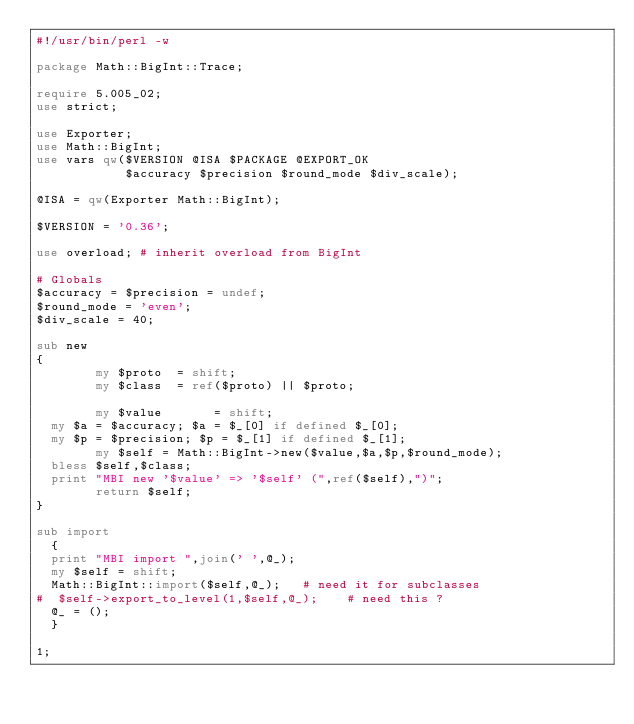Convert code to text. <code><loc_0><loc_0><loc_500><loc_500><_Perl_>#!/usr/bin/perl -w

package Math::BigInt::Trace;

require 5.005_02;
use strict;

use Exporter;
use Math::BigInt;
use vars qw($VERSION @ISA $PACKAGE @EXPORT_OK
            $accuracy $precision $round_mode $div_scale);

@ISA = qw(Exporter Math::BigInt);

$VERSION = '0.36';

use overload;	# inherit overload from BigInt

# Globals
$accuracy = $precision = undef;
$round_mode = 'even';
$div_scale = 40;

sub new
{
        my $proto  = shift;
        my $class  = ref($proto) || $proto;

        my $value       = shift;
	my $a = $accuracy; $a = $_[0] if defined $_[0];
	my $p = $precision; $p = $_[1] if defined $_[1];
        my $self = Math::BigInt->new($value,$a,$p,$round_mode);
	bless $self,$class;
	print "MBI new '$value' => '$self' (",ref($self),")";
        return $self;
}

sub import
  {
  print "MBI import ",join(' ',@_);
  my $self = shift;
  Math::BigInt::import($self,@_);		# need it for subclasses
#  $self->export_to_level(1,$self,@_);		# need this ?
  @_ = ();
  }

1;
</code> 